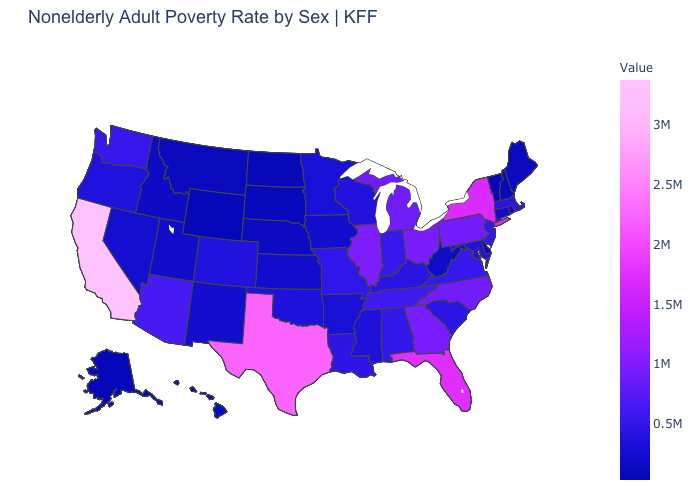Does Wyoming have the lowest value in the USA?
Be succinct. Yes. Which states have the lowest value in the USA?
Be succinct. Wyoming. Among the states that border Pennsylvania , does Delaware have the lowest value?
Concise answer only. Yes. Which states have the highest value in the USA?
Keep it brief. California. 